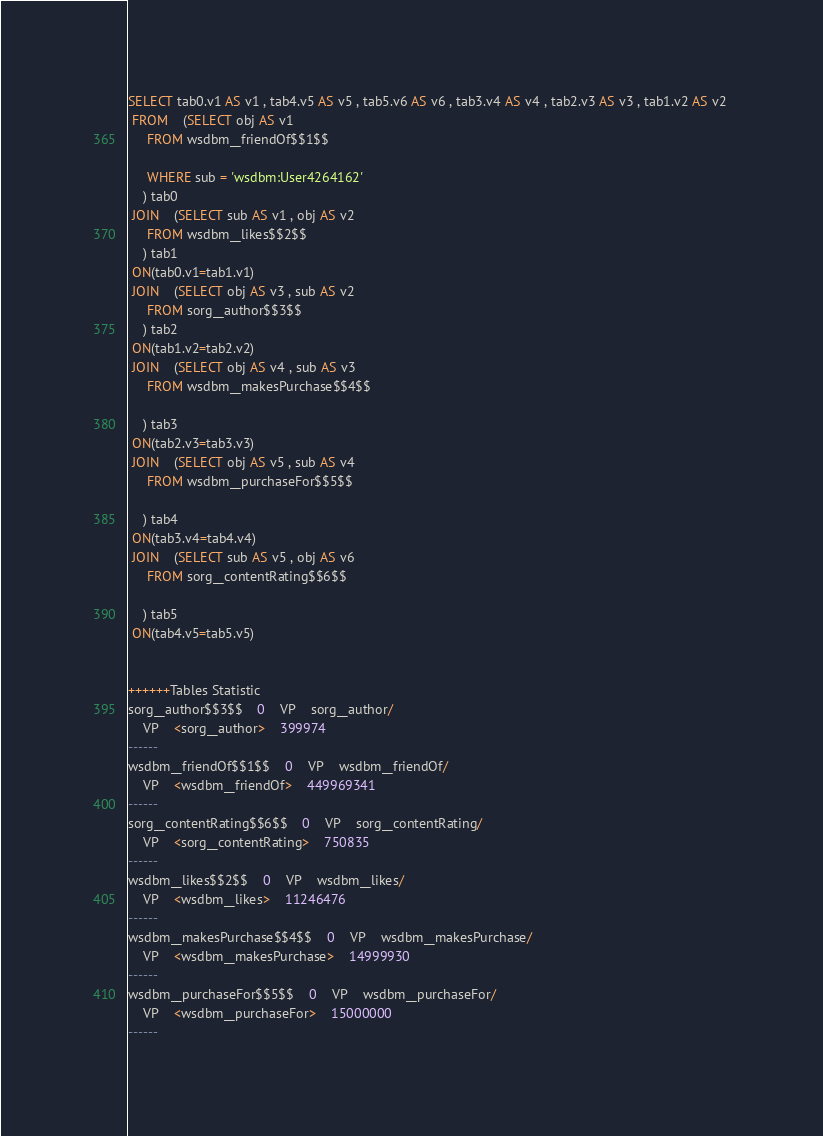Convert code to text. <code><loc_0><loc_0><loc_500><loc_500><_SQL_>SELECT tab0.v1 AS v1 , tab4.v5 AS v5 , tab5.v6 AS v6 , tab3.v4 AS v4 , tab2.v3 AS v3 , tab1.v2 AS v2 
 FROM    (SELECT obj AS v1 
	 FROM wsdbm__friendOf$$1$$
	 
	 WHERE sub = 'wsdbm:User4264162'
	) tab0
 JOIN    (SELECT sub AS v1 , obj AS v2 
	 FROM wsdbm__likes$$2$$
	) tab1
 ON(tab0.v1=tab1.v1)
 JOIN    (SELECT obj AS v3 , sub AS v2 
	 FROM sorg__author$$3$$
	) tab2
 ON(tab1.v2=tab2.v2)
 JOIN    (SELECT obj AS v4 , sub AS v3 
	 FROM wsdbm__makesPurchase$$4$$
	
	) tab3
 ON(tab2.v3=tab3.v3)
 JOIN    (SELECT obj AS v5 , sub AS v4 
	 FROM wsdbm__purchaseFor$$5$$
	
	) tab4
 ON(tab3.v4=tab4.v4)
 JOIN    (SELECT sub AS v5 , obj AS v6 
	 FROM sorg__contentRating$$6$$
	
	) tab5
 ON(tab4.v5=tab5.v5)


++++++Tables Statistic
sorg__author$$3$$	0	VP	sorg__author/
	VP	<sorg__author>	399974
------
wsdbm__friendOf$$1$$	0	VP	wsdbm__friendOf/
	VP	<wsdbm__friendOf>	449969341
------
sorg__contentRating$$6$$	0	VP	sorg__contentRating/
	VP	<sorg__contentRating>	750835
------
wsdbm__likes$$2$$	0	VP	wsdbm__likes/
	VP	<wsdbm__likes>	11246476
------
wsdbm__makesPurchase$$4$$	0	VP	wsdbm__makesPurchase/
	VP	<wsdbm__makesPurchase>	14999930
------
wsdbm__purchaseFor$$5$$	0	VP	wsdbm__purchaseFor/
	VP	<wsdbm__purchaseFor>	15000000
------
</code> 